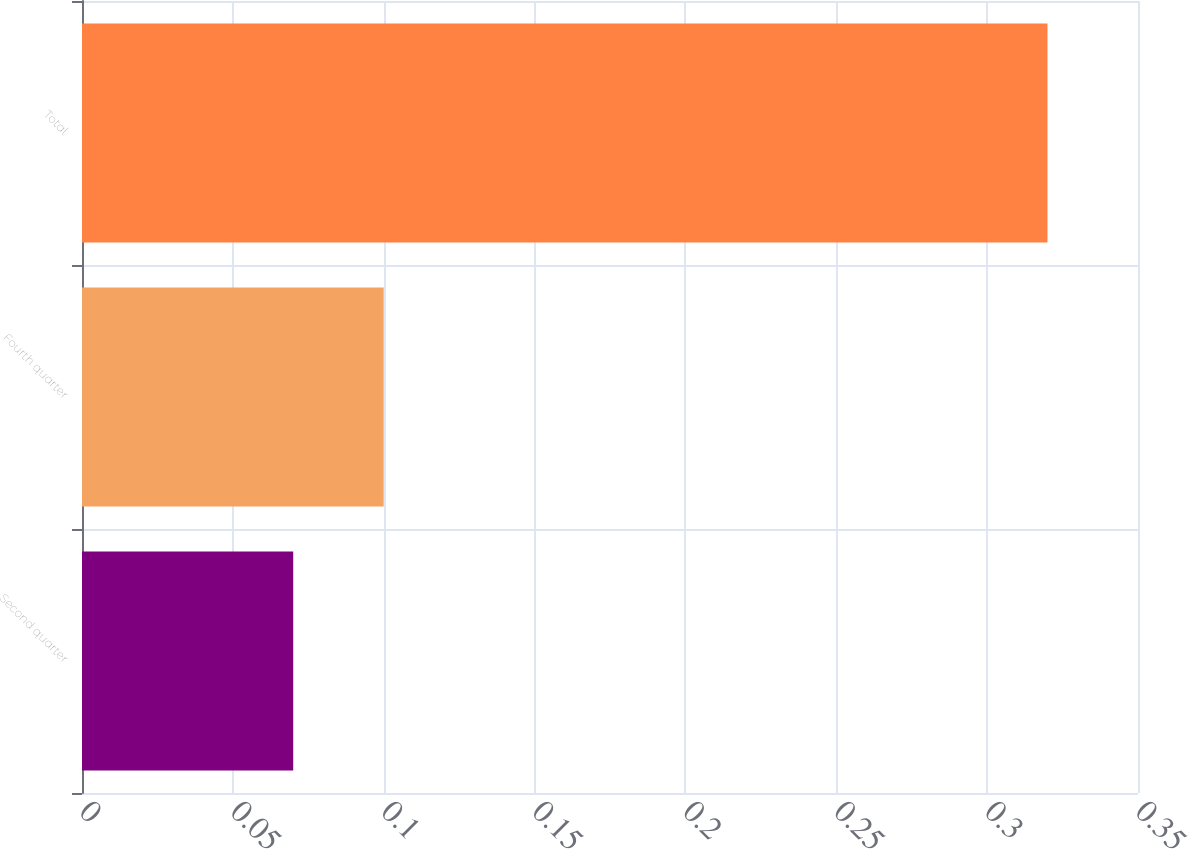Convert chart to OTSL. <chart><loc_0><loc_0><loc_500><loc_500><bar_chart><fcel>Second quarter<fcel>Fourth quarter<fcel>Total<nl><fcel>0.07<fcel>0.1<fcel>0.32<nl></chart> 